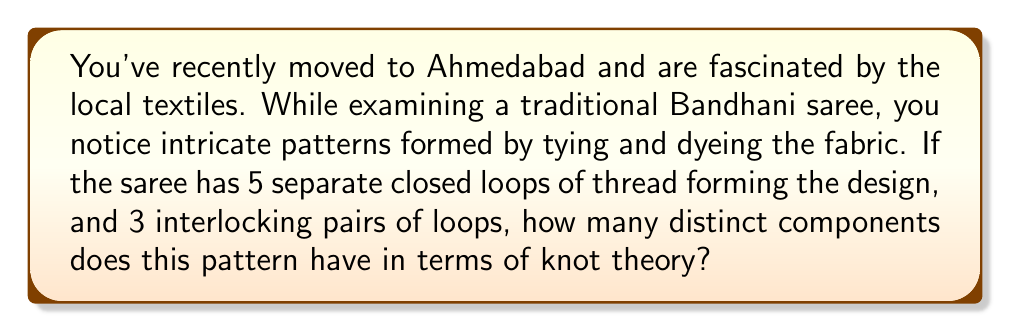Could you help me with this problem? Let's approach this step-by-step:

1) In knot theory, we distinguish between knots and links:
   - A knot is a single closed loop in 3-dimensional space.
   - A link is a collection of one or more knots that may be interlinked.

2) In this Bandhani saree pattern:
   - We have 5 separate closed loops, which are individual knots.
   - We also have 3 interlocking pairs of loops, which are links.

3) Let's count the components:
   - Each of the 5 separate loops counts as 1 component: 5 components
   - For the 3 interlocking pairs:
     * Each pair forms a link, which is 1 component
     * So the 3 pairs contribute 3 more components

4) Total number of components:
   $$ \text{Total components} = \text{Separate loops} + \text{Interlocking pairs} $$
   $$ \text{Total components} = 5 + 3 = 8 $$

5) In knot theory terms:
   - The 5 separate loops are trivial knots (also called unknots)
   - The 3 interlocking pairs are likely Hopf links (the simplest non-trivial link)

This pattern in the Bandhani saree thus represents a link with 8 distinct components in knot theory, showcasing both knots (the separate loops) and links (the interlocking pairs) in a single textile design.
Answer: 8 components 